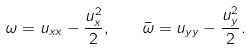<formula> <loc_0><loc_0><loc_500><loc_500>\omega = u _ { x x } - \frac { u _ { x } ^ { 2 } } { 2 } , \quad \bar { \omega } = u _ { y y } - \frac { u _ { y } ^ { 2 } } { 2 } .</formula> 